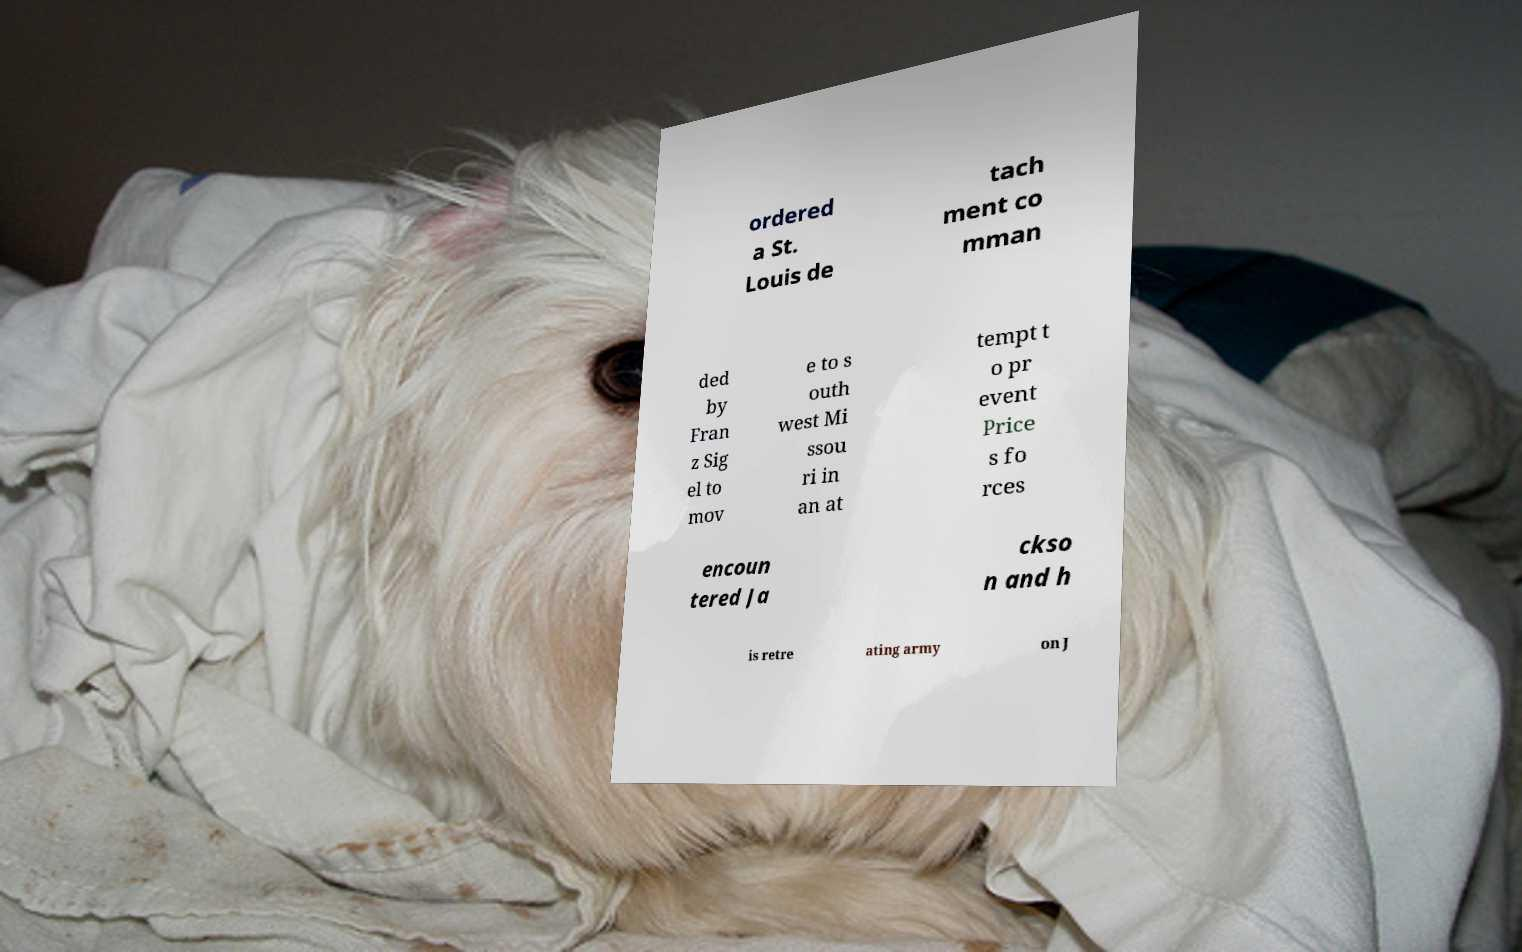There's text embedded in this image that I need extracted. Can you transcribe it verbatim? ordered a St. Louis de tach ment co mman ded by Fran z Sig el to mov e to s outh west Mi ssou ri in an at tempt t o pr event Price s fo rces encoun tered Ja ckso n and h is retre ating army on J 